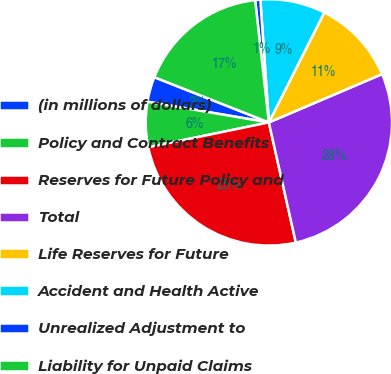<chart> <loc_0><loc_0><loc_500><loc_500><pie_chart><fcel>(in millions of dollars)<fcel>Policy and Contract Benefits<fcel>Reserves for Future Policy and<fcel>Total<fcel>Life Reserves for Future<fcel>Accident and Health Active<fcel>Unrealized Adjustment to<fcel>Liability for Unpaid Claims<nl><fcel>3.3%<fcel>5.92%<fcel>25.28%<fcel>27.9%<fcel>11.15%<fcel>8.53%<fcel>0.68%<fcel>17.23%<nl></chart> 